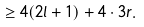<formula> <loc_0><loc_0><loc_500><loc_500>\geq 4 ( 2 l + 1 ) + 4 \cdot 3 r .</formula> 